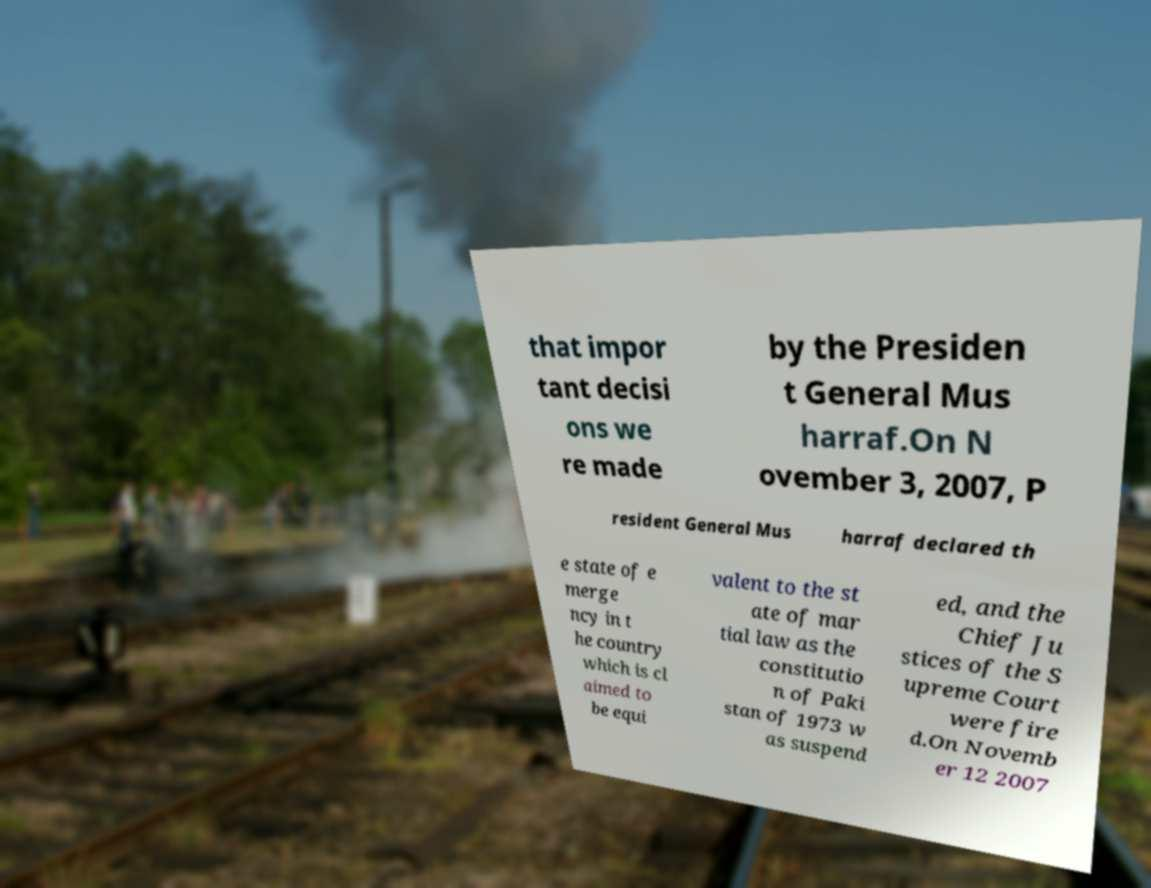For documentation purposes, I need the text within this image transcribed. Could you provide that? that impor tant decisi ons we re made by the Presiden t General Mus harraf.On N ovember 3, 2007, P resident General Mus harraf declared th e state of e merge ncy in t he country which is cl aimed to be equi valent to the st ate of mar tial law as the constitutio n of Paki stan of 1973 w as suspend ed, and the Chief Ju stices of the S upreme Court were fire d.On Novemb er 12 2007 